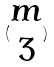<formula> <loc_0><loc_0><loc_500><loc_500>( \begin{matrix} m \\ 3 \end{matrix} )</formula> 